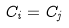Convert formula to latex. <formula><loc_0><loc_0><loc_500><loc_500>C _ { i } = C _ { j }</formula> 